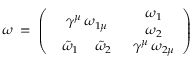Convert formula to latex. <formula><loc_0><loc_0><loc_500><loc_500>\omega \, = \, \left ( \begin{array} { c c } { { \gamma ^ { \mu } \, \omega _ { 1 \mu } } } & { { \begin{array} { c } { { \omega _ { 1 } } } \\ { { \omega _ { 2 } } } \end{array} } } \\ { { \begin{array} { c c } { { \tilde { \omega } _ { 1 } \, } } & { { \tilde { \omega } _ { 2 } } } \end{array} } } & { { \gamma ^ { \mu } \, \omega _ { 2 \mu } } } \end{array} \right )</formula> 